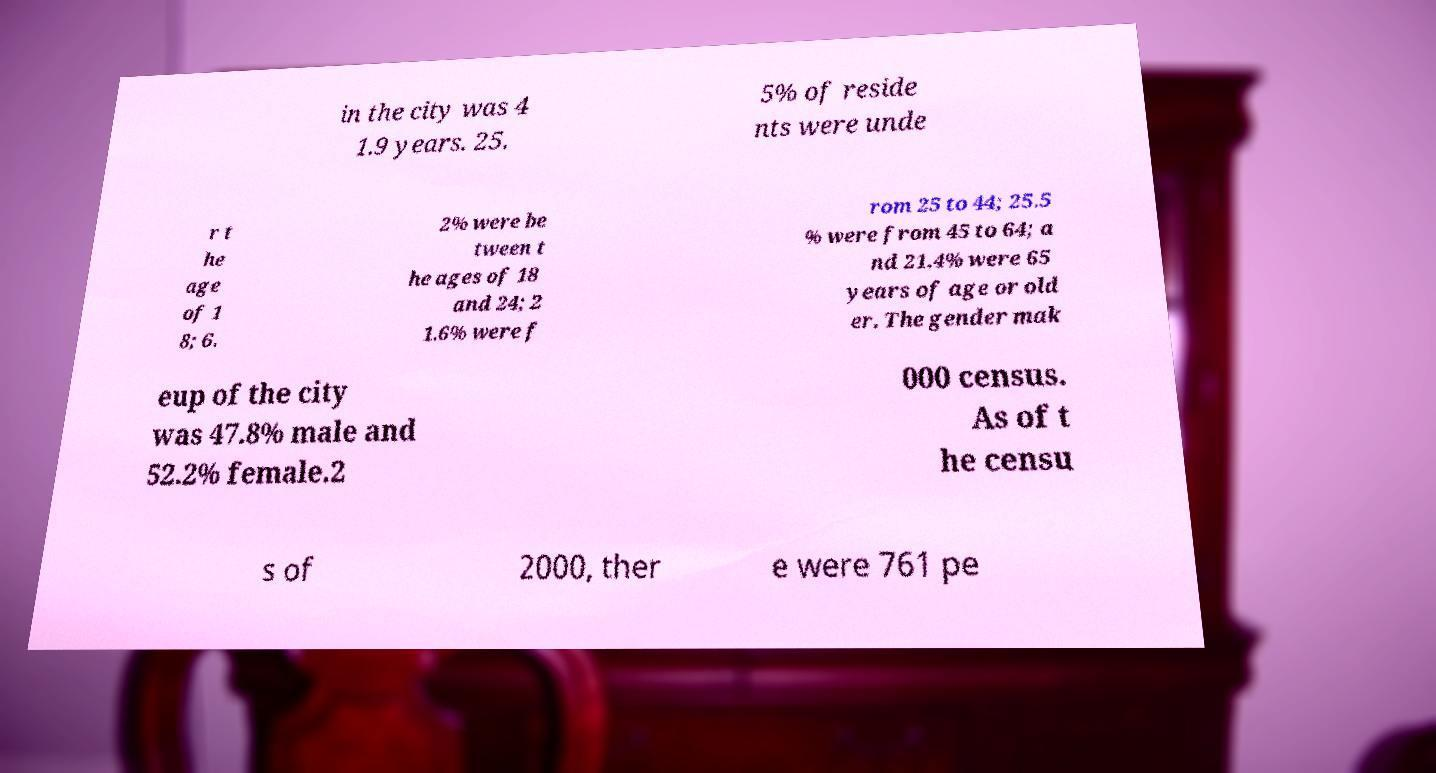Could you assist in decoding the text presented in this image and type it out clearly? in the city was 4 1.9 years. 25. 5% of reside nts were unde r t he age of 1 8; 6. 2% were be tween t he ages of 18 and 24; 2 1.6% were f rom 25 to 44; 25.5 % were from 45 to 64; a nd 21.4% were 65 years of age or old er. The gender mak eup of the city was 47.8% male and 52.2% female.2 000 census. As of t he censu s of 2000, ther e were 761 pe 